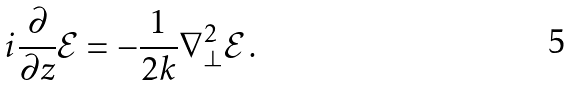Convert formula to latex. <formula><loc_0><loc_0><loc_500><loc_500>i \frac { \partial } { \partial z } \mathcal { E } = - \frac { 1 } { 2 k } \nabla _ { \bot } ^ { 2 } \mathcal { E } \, .</formula> 